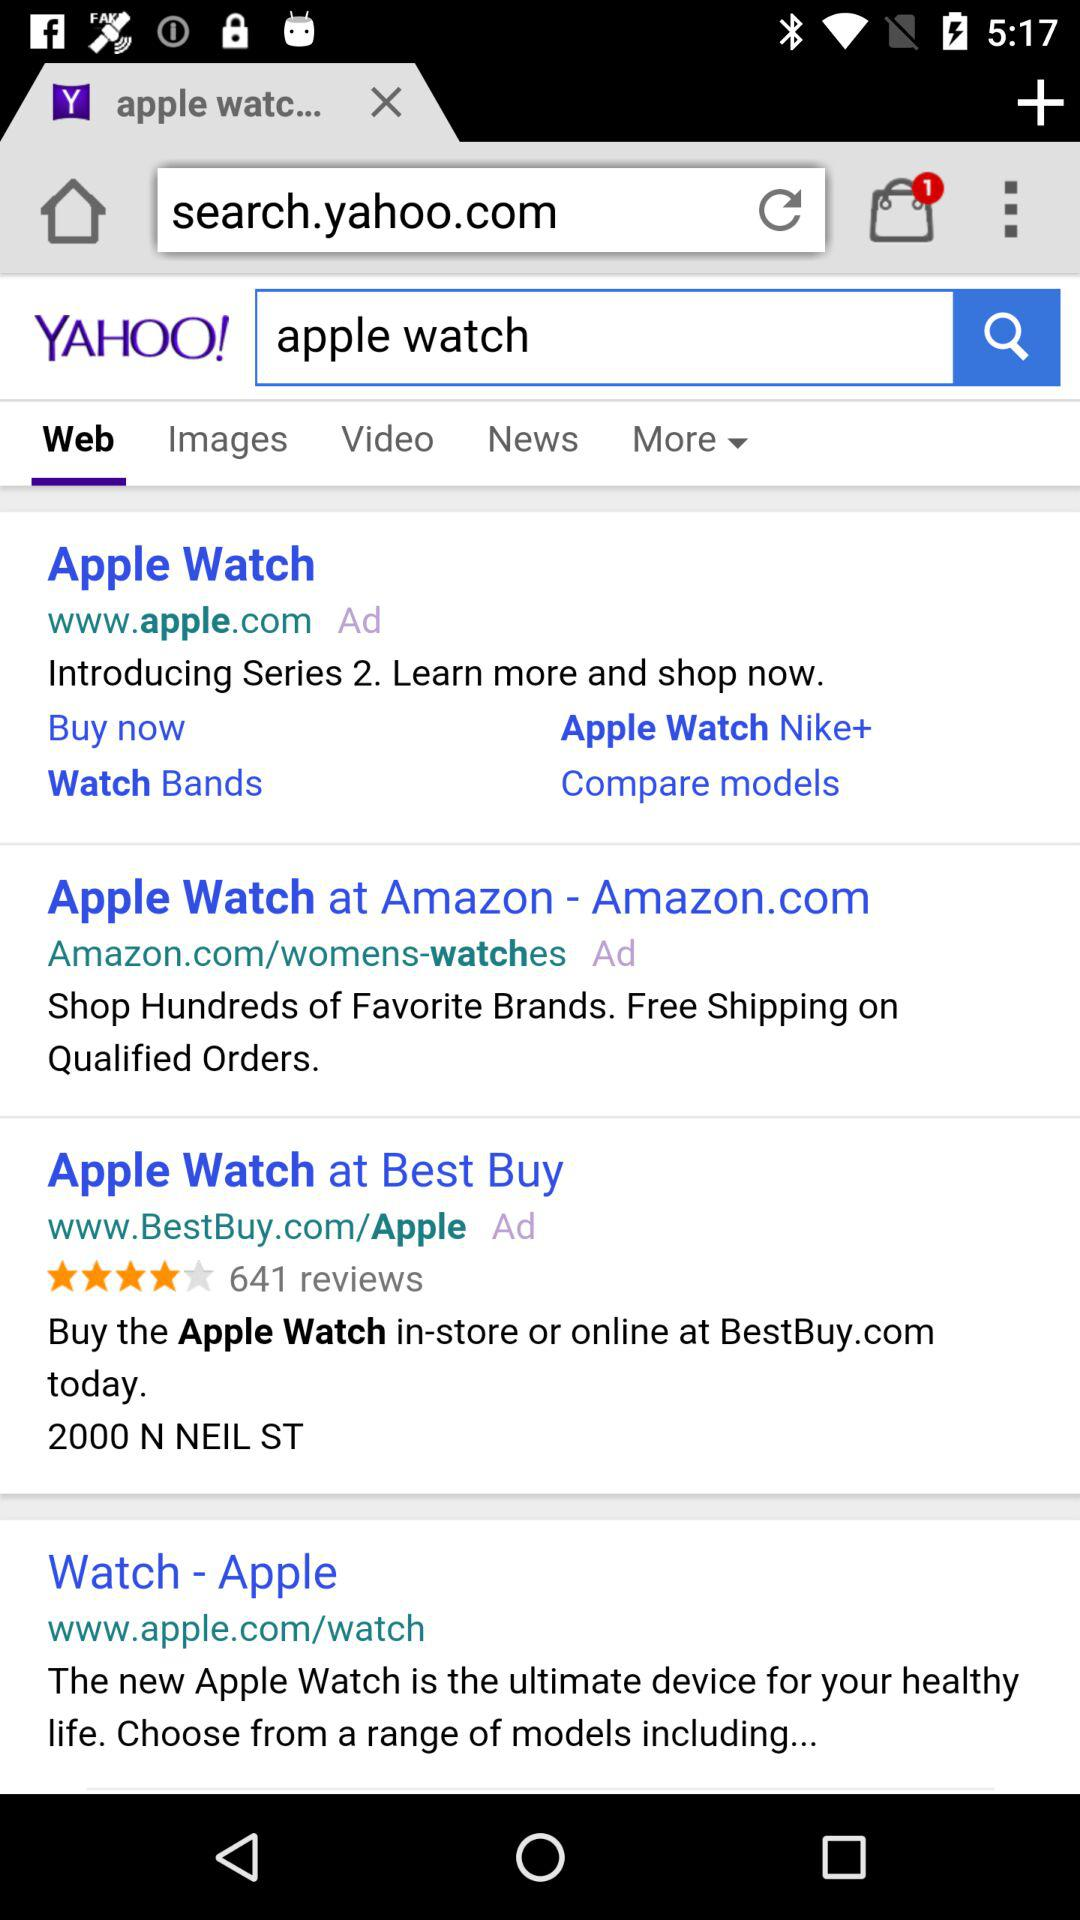What is the number of notifications? The number of notifications is 1. 